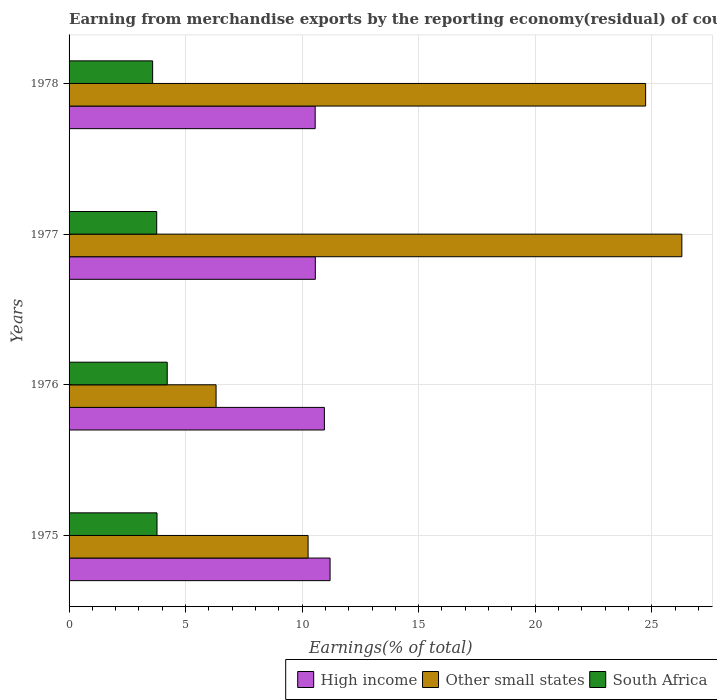How many groups of bars are there?
Make the answer very short. 4. How many bars are there on the 4th tick from the top?
Offer a terse response. 3. How many bars are there on the 1st tick from the bottom?
Offer a terse response. 3. What is the label of the 3rd group of bars from the top?
Provide a succinct answer. 1976. In how many cases, is the number of bars for a given year not equal to the number of legend labels?
Offer a very short reply. 0. What is the percentage of amount earned from merchandise exports in Other small states in 1976?
Offer a very short reply. 6.31. Across all years, what is the maximum percentage of amount earned from merchandise exports in Other small states?
Your answer should be compact. 26.29. Across all years, what is the minimum percentage of amount earned from merchandise exports in High income?
Your answer should be compact. 10.56. In which year was the percentage of amount earned from merchandise exports in South Africa maximum?
Offer a very short reply. 1976. In which year was the percentage of amount earned from merchandise exports in South Africa minimum?
Give a very brief answer. 1978. What is the total percentage of amount earned from merchandise exports in High income in the graph?
Make the answer very short. 43.28. What is the difference between the percentage of amount earned from merchandise exports in South Africa in 1975 and that in 1978?
Your response must be concise. 0.19. What is the difference between the percentage of amount earned from merchandise exports in High income in 1978 and the percentage of amount earned from merchandise exports in Other small states in 1975?
Your answer should be very brief. 0.3. What is the average percentage of amount earned from merchandise exports in South Africa per year?
Provide a succinct answer. 3.83. In the year 1976, what is the difference between the percentage of amount earned from merchandise exports in High income and percentage of amount earned from merchandise exports in Other small states?
Make the answer very short. 4.65. In how many years, is the percentage of amount earned from merchandise exports in High income greater than 25 %?
Give a very brief answer. 0. What is the ratio of the percentage of amount earned from merchandise exports in Other small states in 1975 to that in 1977?
Ensure brevity in your answer.  0.39. What is the difference between the highest and the second highest percentage of amount earned from merchandise exports in South Africa?
Your answer should be very brief. 0.44. What is the difference between the highest and the lowest percentage of amount earned from merchandise exports in Other small states?
Your answer should be very brief. 19.99. In how many years, is the percentage of amount earned from merchandise exports in South Africa greater than the average percentage of amount earned from merchandise exports in South Africa taken over all years?
Make the answer very short. 1. What does the 3rd bar from the bottom in 1976 represents?
Offer a terse response. South Africa. Is it the case that in every year, the sum of the percentage of amount earned from merchandise exports in South Africa and percentage of amount earned from merchandise exports in Other small states is greater than the percentage of amount earned from merchandise exports in High income?
Offer a very short reply. No. How many bars are there?
Ensure brevity in your answer.  12. How many years are there in the graph?
Keep it short and to the point. 4. Does the graph contain any zero values?
Give a very brief answer. No. Where does the legend appear in the graph?
Make the answer very short. Bottom right. How are the legend labels stacked?
Offer a very short reply. Horizontal. What is the title of the graph?
Make the answer very short. Earning from merchandise exports by the reporting economy(residual) of countries. Does "Honduras" appear as one of the legend labels in the graph?
Your answer should be very brief. No. What is the label or title of the X-axis?
Your answer should be compact. Earnings(% of total). What is the Earnings(% of total) of High income in 1975?
Give a very brief answer. 11.2. What is the Earnings(% of total) in Other small states in 1975?
Your answer should be compact. 10.26. What is the Earnings(% of total) in South Africa in 1975?
Make the answer very short. 3.77. What is the Earnings(% of total) in High income in 1976?
Make the answer very short. 10.96. What is the Earnings(% of total) of Other small states in 1976?
Give a very brief answer. 6.31. What is the Earnings(% of total) in South Africa in 1976?
Your answer should be compact. 4.21. What is the Earnings(% of total) of High income in 1977?
Your answer should be compact. 10.57. What is the Earnings(% of total) of Other small states in 1977?
Ensure brevity in your answer.  26.29. What is the Earnings(% of total) in South Africa in 1977?
Give a very brief answer. 3.76. What is the Earnings(% of total) in High income in 1978?
Your answer should be compact. 10.56. What is the Earnings(% of total) of Other small states in 1978?
Make the answer very short. 24.74. What is the Earnings(% of total) of South Africa in 1978?
Provide a succinct answer. 3.59. Across all years, what is the maximum Earnings(% of total) in High income?
Your answer should be compact. 11.2. Across all years, what is the maximum Earnings(% of total) in Other small states?
Ensure brevity in your answer.  26.29. Across all years, what is the maximum Earnings(% of total) of South Africa?
Your answer should be compact. 4.21. Across all years, what is the minimum Earnings(% of total) in High income?
Keep it short and to the point. 10.56. Across all years, what is the minimum Earnings(% of total) in Other small states?
Provide a short and direct response. 6.31. Across all years, what is the minimum Earnings(% of total) in South Africa?
Offer a very short reply. 3.59. What is the total Earnings(% of total) in High income in the graph?
Keep it short and to the point. 43.28. What is the total Earnings(% of total) in Other small states in the graph?
Your response must be concise. 67.6. What is the total Earnings(% of total) in South Africa in the graph?
Provide a succinct answer. 15.33. What is the difference between the Earnings(% of total) of High income in 1975 and that in 1976?
Give a very brief answer. 0.24. What is the difference between the Earnings(% of total) in Other small states in 1975 and that in 1976?
Your answer should be compact. 3.95. What is the difference between the Earnings(% of total) in South Africa in 1975 and that in 1976?
Ensure brevity in your answer.  -0.44. What is the difference between the Earnings(% of total) in High income in 1975 and that in 1977?
Your answer should be very brief. 0.63. What is the difference between the Earnings(% of total) in Other small states in 1975 and that in 1977?
Offer a terse response. -16.04. What is the difference between the Earnings(% of total) of South Africa in 1975 and that in 1977?
Keep it short and to the point. 0.01. What is the difference between the Earnings(% of total) in High income in 1975 and that in 1978?
Give a very brief answer. 0.64. What is the difference between the Earnings(% of total) of Other small states in 1975 and that in 1978?
Your answer should be compact. -14.48. What is the difference between the Earnings(% of total) in South Africa in 1975 and that in 1978?
Offer a very short reply. 0.19. What is the difference between the Earnings(% of total) of High income in 1976 and that in 1977?
Give a very brief answer. 0.39. What is the difference between the Earnings(% of total) in Other small states in 1976 and that in 1977?
Your answer should be very brief. -19.99. What is the difference between the Earnings(% of total) in South Africa in 1976 and that in 1977?
Provide a succinct answer. 0.45. What is the difference between the Earnings(% of total) in High income in 1976 and that in 1978?
Provide a succinct answer. 0.39. What is the difference between the Earnings(% of total) of Other small states in 1976 and that in 1978?
Your response must be concise. -18.43. What is the difference between the Earnings(% of total) of South Africa in 1976 and that in 1978?
Your answer should be compact. 0.63. What is the difference between the Earnings(% of total) of High income in 1977 and that in 1978?
Ensure brevity in your answer.  0.01. What is the difference between the Earnings(% of total) of Other small states in 1977 and that in 1978?
Offer a terse response. 1.55. What is the difference between the Earnings(% of total) in South Africa in 1977 and that in 1978?
Your answer should be compact. 0.17. What is the difference between the Earnings(% of total) of High income in 1975 and the Earnings(% of total) of Other small states in 1976?
Your answer should be very brief. 4.89. What is the difference between the Earnings(% of total) of High income in 1975 and the Earnings(% of total) of South Africa in 1976?
Make the answer very short. 6.99. What is the difference between the Earnings(% of total) of Other small states in 1975 and the Earnings(% of total) of South Africa in 1976?
Your response must be concise. 6.04. What is the difference between the Earnings(% of total) in High income in 1975 and the Earnings(% of total) in Other small states in 1977?
Provide a short and direct response. -15.09. What is the difference between the Earnings(% of total) of High income in 1975 and the Earnings(% of total) of South Africa in 1977?
Ensure brevity in your answer.  7.44. What is the difference between the Earnings(% of total) of Other small states in 1975 and the Earnings(% of total) of South Africa in 1977?
Your answer should be compact. 6.5. What is the difference between the Earnings(% of total) in High income in 1975 and the Earnings(% of total) in Other small states in 1978?
Keep it short and to the point. -13.54. What is the difference between the Earnings(% of total) of High income in 1975 and the Earnings(% of total) of South Africa in 1978?
Provide a short and direct response. 7.61. What is the difference between the Earnings(% of total) in Other small states in 1975 and the Earnings(% of total) in South Africa in 1978?
Your answer should be compact. 6.67. What is the difference between the Earnings(% of total) of High income in 1976 and the Earnings(% of total) of Other small states in 1977?
Offer a very short reply. -15.34. What is the difference between the Earnings(% of total) of High income in 1976 and the Earnings(% of total) of South Africa in 1977?
Make the answer very short. 7.19. What is the difference between the Earnings(% of total) of Other small states in 1976 and the Earnings(% of total) of South Africa in 1977?
Keep it short and to the point. 2.55. What is the difference between the Earnings(% of total) of High income in 1976 and the Earnings(% of total) of Other small states in 1978?
Give a very brief answer. -13.78. What is the difference between the Earnings(% of total) in High income in 1976 and the Earnings(% of total) in South Africa in 1978?
Your answer should be very brief. 7.37. What is the difference between the Earnings(% of total) of Other small states in 1976 and the Earnings(% of total) of South Africa in 1978?
Provide a succinct answer. 2.72. What is the difference between the Earnings(% of total) in High income in 1977 and the Earnings(% of total) in Other small states in 1978?
Give a very brief answer. -14.17. What is the difference between the Earnings(% of total) in High income in 1977 and the Earnings(% of total) in South Africa in 1978?
Your response must be concise. 6.98. What is the difference between the Earnings(% of total) of Other small states in 1977 and the Earnings(% of total) of South Africa in 1978?
Offer a terse response. 22.71. What is the average Earnings(% of total) in High income per year?
Your answer should be very brief. 10.82. What is the average Earnings(% of total) of Other small states per year?
Offer a terse response. 16.9. What is the average Earnings(% of total) of South Africa per year?
Offer a very short reply. 3.83. In the year 1975, what is the difference between the Earnings(% of total) in High income and Earnings(% of total) in Other small states?
Ensure brevity in your answer.  0.94. In the year 1975, what is the difference between the Earnings(% of total) of High income and Earnings(% of total) of South Africa?
Give a very brief answer. 7.43. In the year 1975, what is the difference between the Earnings(% of total) of Other small states and Earnings(% of total) of South Africa?
Give a very brief answer. 6.48. In the year 1976, what is the difference between the Earnings(% of total) in High income and Earnings(% of total) in Other small states?
Provide a short and direct response. 4.65. In the year 1976, what is the difference between the Earnings(% of total) in High income and Earnings(% of total) in South Africa?
Your answer should be compact. 6.74. In the year 1976, what is the difference between the Earnings(% of total) in Other small states and Earnings(% of total) in South Africa?
Offer a terse response. 2.1. In the year 1977, what is the difference between the Earnings(% of total) of High income and Earnings(% of total) of Other small states?
Make the answer very short. -15.73. In the year 1977, what is the difference between the Earnings(% of total) of High income and Earnings(% of total) of South Africa?
Keep it short and to the point. 6.81. In the year 1977, what is the difference between the Earnings(% of total) of Other small states and Earnings(% of total) of South Africa?
Ensure brevity in your answer.  22.53. In the year 1978, what is the difference between the Earnings(% of total) of High income and Earnings(% of total) of Other small states?
Make the answer very short. -14.18. In the year 1978, what is the difference between the Earnings(% of total) of High income and Earnings(% of total) of South Africa?
Offer a very short reply. 6.97. In the year 1978, what is the difference between the Earnings(% of total) in Other small states and Earnings(% of total) in South Africa?
Offer a terse response. 21.15. What is the ratio of the Earnings(% of total) of High income in 1975 to that in 1976?
Provide a succinct answer. 1.02. What is the ratio of the Earnings(% of total) in Other small states in 1975 to that in 1976?
Provide a succinct answer. 1.63. What is the ratio of the Earnings(% of total) of South Africa in 1975 to that in 1976?
Ensure brevity in your answer.  0.9. What is the ratio of the Earnings(% of total) of High income in 1975 to that in 1977?
Provide a succinct answer. 1.06. What is the ratio of the Earnings(% of total) of Other small states in 1975 to that in 1977?
Keep it short and to the point. 0.39. What is the ratio of the Earnings(% of total) in South Africa in 1975 to that in 1977?
Your answer should be very brief. 1. What is the ratio of the Earnings(% of total) of High income in 1975 to that in 1978?
Provide a succinct answer. 1.06. What is the ratio of the Earnings(% of total) in Other small states in 1975 to that in 1978?
Offer a very short reply. 0.41. What is the ratio of the Earnings(% of total) in South Africa in 1975 to that in 1978?
Your answer should be very brief. 1.05. What is the ratio of the Earnings(% of total) of High income in 1976 to that in 1977?
Keep it short and to the point. 1.04. What is the ratio of the Earnings(% of total) of Other small states in 1976 to that in 1977?
Provide a succinct answer. 0.24. What is the ratio of the Earnings(% of total) of South Africa in 1976 to that in 1977?
Offer a terse response. 1.12. What is the ratio of the Earnings(% of total) of High income in 1976 to that in 1978?
Keep it short and to the point. 1.04. What is the ratio of the Earnings(% of total) in Other small states in 1976 to that in 1978?
Offer a terse response. 0.26. What is the ratio of the Earnings(% of total) of South Africa in 1976 to that in 1978?
Ensure brevity in your answer.  1.17. What is the ratio of the Earnings(% of total) of High income in 1977 to that in 1978?
Provide a succinct answer. 1. What is the ratio of the Earnings(% of total) in Other small states in 1977 to that in 1978?
Provide a short and direct response. 1.06. What is the ratio of the Earnings(% of total) of South Africa in 1977 to that in 1978?
Your answer should be compact. 1.05. What is the difference between the highest and the second highest Earnings(% of total) in High income?
Give a very brief answer. 0.24. What is the difference between the highest and the second highest Earnings(% of total) of Other small states?
Your answer should be very brief. 1.55. What is the difference between the highest and the second highest Earnings(% of total) of South Africa?
Offer a terse response. 0.44. What is the difference between the highest and the lowest Earnings(% of total) of High income?
Keep it short and to the point. 0.64. What is the difference between the highest and the lowest Earnings(% of total) in Other small states?
Offer a very short reply. 19.99. What is the difference between the highest and the lowest Earnings(% of total) of South Africa?
Give a very brief answer. 0.63. 